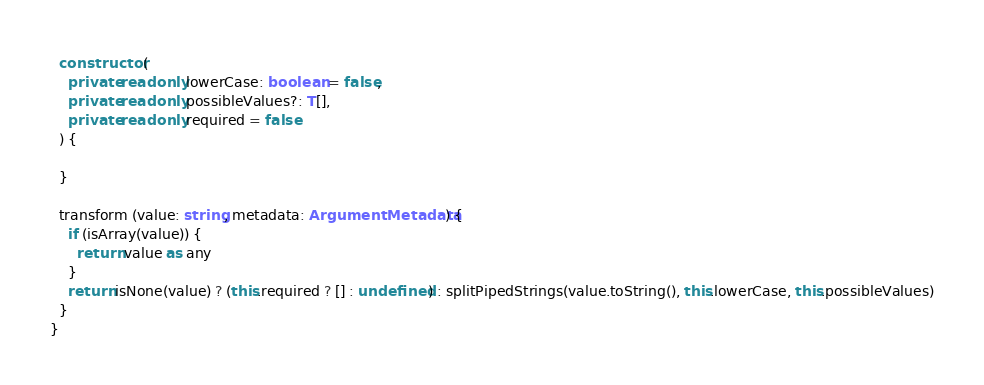<code> <loc_0><loc_0><loc_500><loc_500><_TypeScript_>  constructor (
    private readonly lowerCase: boolean = false,
    private readonly possibleValues?: T[],
    private readonly required = false
  ) {

  }

  transform (value: string, metadata: ArgumentMetadata) {
    if (isArray(value)) {
      return value as any
    }
    return isNone(value) ? (this.required ? [] : undefined) : splitPipedStrings(value.toString(), this.lowerCase, this.possibleValues)
  }
}
</code> 